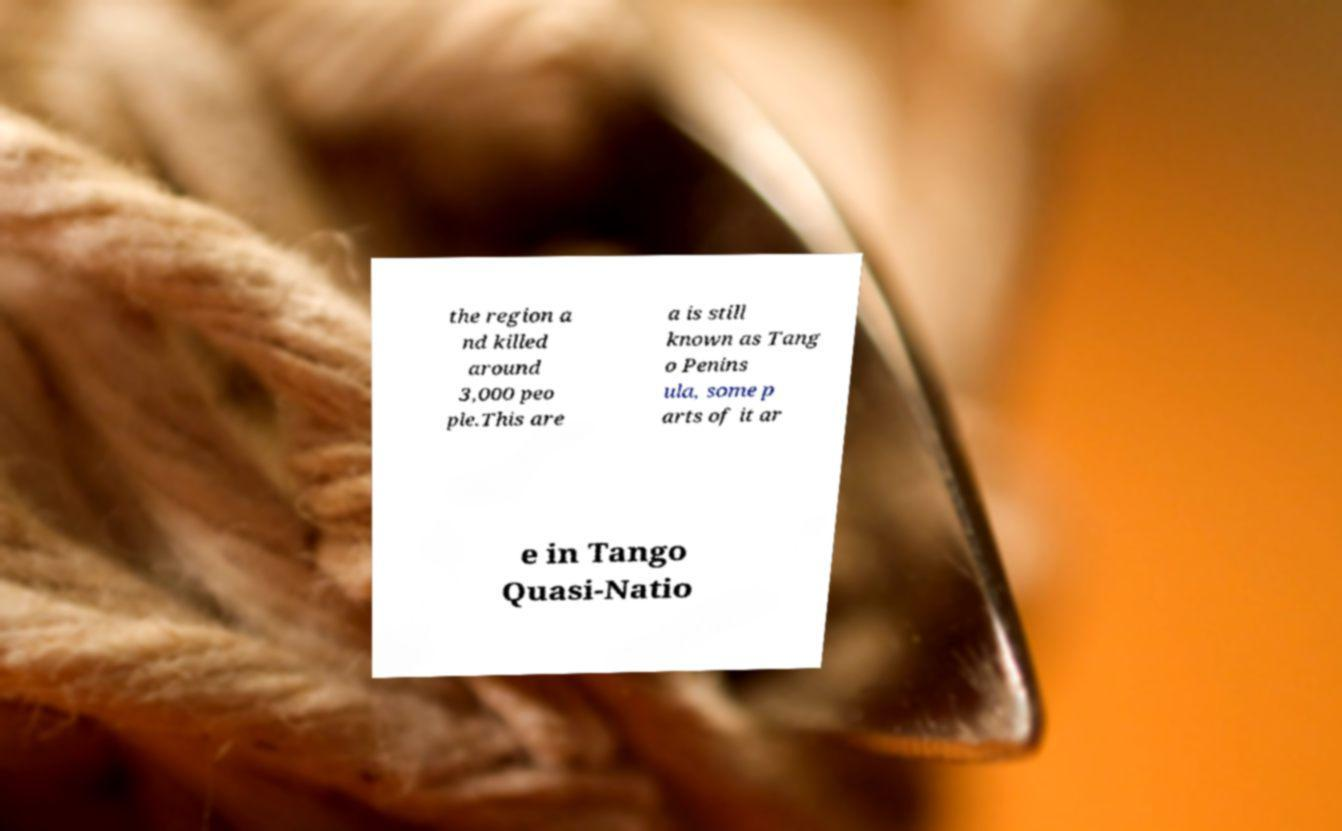Could you extract and type out the text from this image? the region a nd killed around 3,000 peo ple.This are a is still known as Tang o Penins ula, some p arts of it ar e in Tango Quasi-Natio 